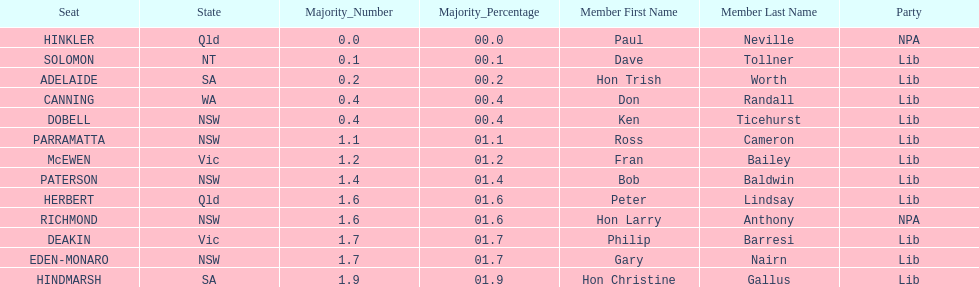How many members in total? 13. 